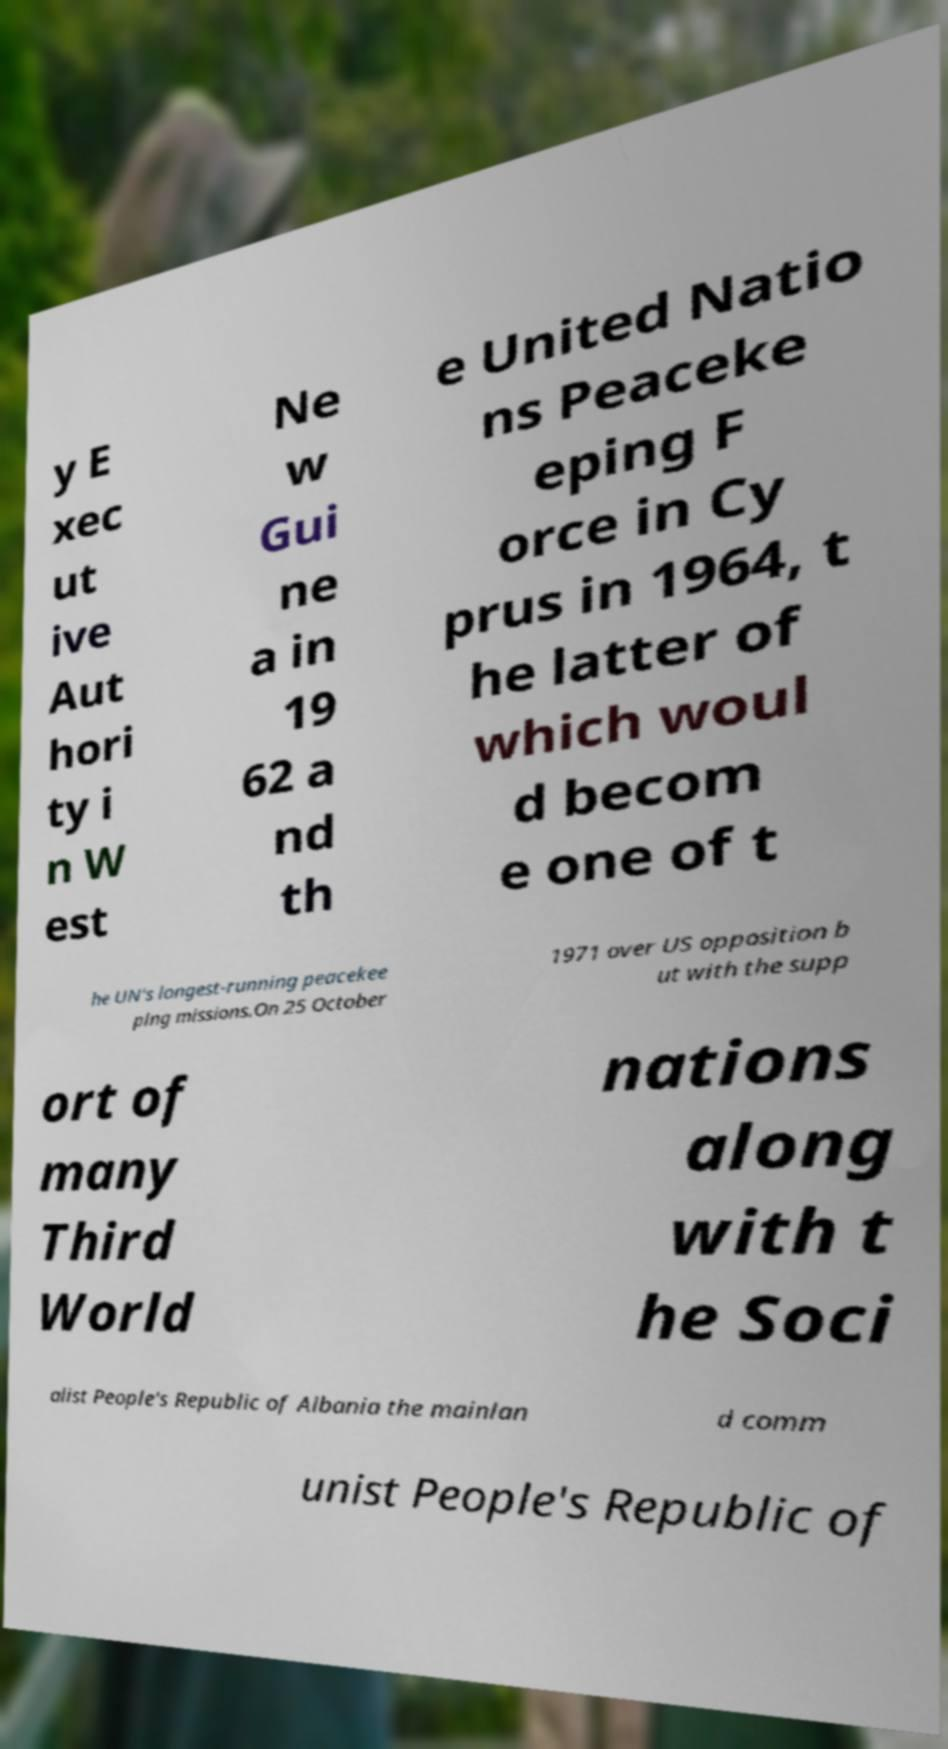For documentation purposes, I need the text within this image transcribed. Could you provide that? y E xec ut ive Aut hori ty i n W est Ne w Gui ne a in 19 62 a nd th e United Natio ns Peaceke eping F orce in Cy prus in 1964, t he latter of which woul d becom e one of t he UN's longest-running peacekee ping missions.On 25 October 1971 over US opposition b ut with the supp ort of many Third World nations along with t he Soci alist People's Republic of Albania the mainlan d comm unist People's Republic of 